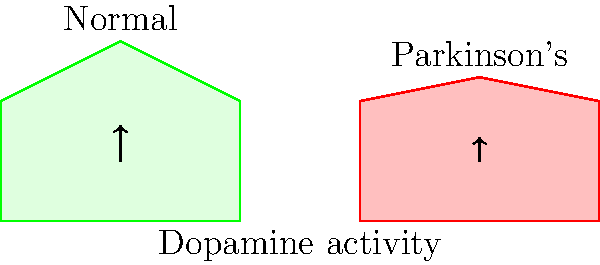Based on the PET scan images shown, which key difference would you expect to observe in dopamine activity between a normal brain and a brain affected by Parkinson's disease? To answer this question, let's analyze the PET scan images step-by-step:

1. The image shows two brain scans: one labeled "Normal" and the other labeled "Parkinson's."

2. In PET scans, brighter colors (represented by higher peaks in this 2D representation) typically indicate higher metabolic activity or neurotransmitter function.

3. The normal brain scan shows a higher peak (represented by the green area), particularly in the central region where the arrow is pointing. This area likely represents the basal ganglia, which is rich in dopamine-producing neurons.

4. The Parkinson's brain scan shows a lower, flatter peak (represented by the red area) in the corresponding region.

5. Parkinson's disease is characterized by a loss of dopamine-producing neurons in the substantia nigra, which projects to the basal ganglia.

6. This loss of dopamine-producing neurons results in decreased dopamine activity in the basal ganglia.

7. The difference in peak heights between the two scans visually represents this decrease in dopamine activity.

Therefore, based on these PET scan images, we would expect to observe decreased dopamine activity in the brain affected by Parkinson's disease compared to the normal brain.
Answer: Decreased dopamine activity in Parkinson's brain 